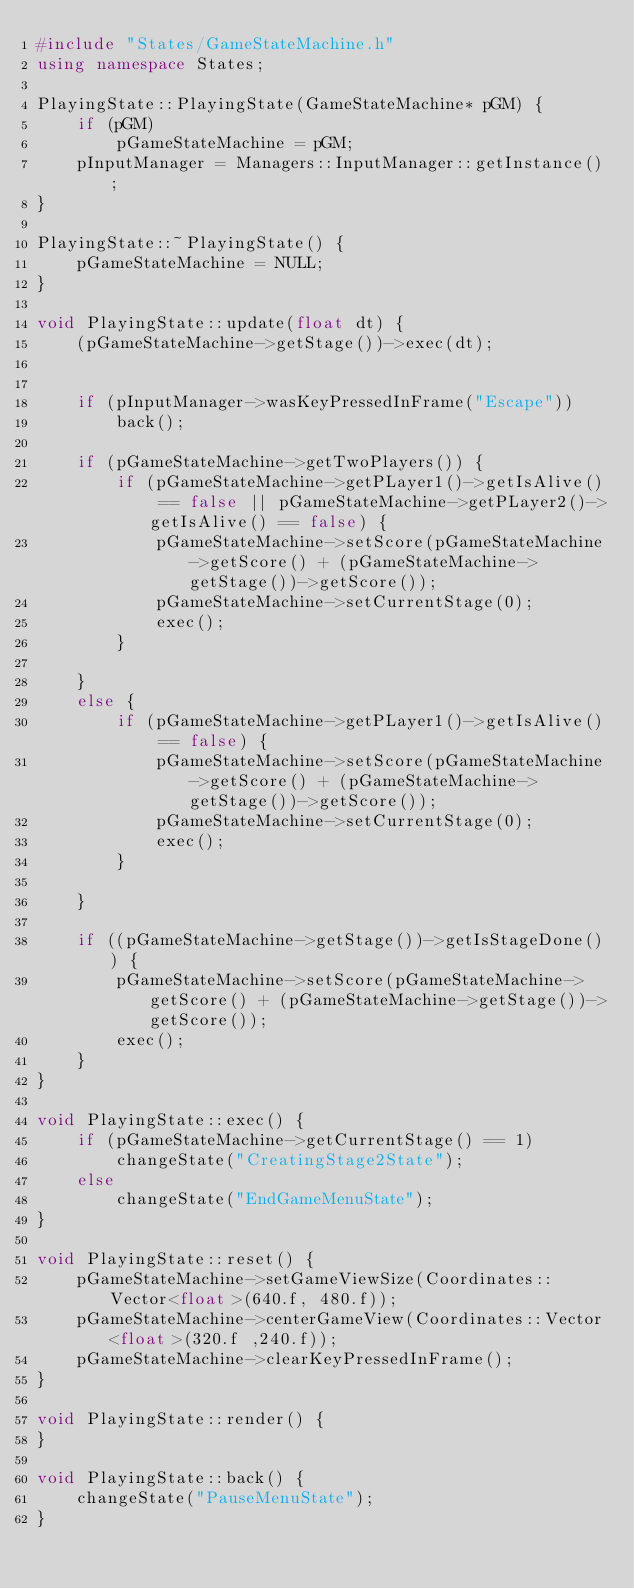<code> <loc_0><loc_0><loc_500><loc_500><_C++_>#include "States/GameStateMachine.h"
using namespace States;

PlayingState::PlayingState(GameStateMachine* pGM) {
    if (pGM)
        pGameStateMachine = pGM;
    pInputManager = Managers::InputManager::getInstance();
}

PlayingState::~PlayingState() {
    pGameStateMachine = NULL;
}

void PlayingState::update(float dt) {
    (pGameStateMachine->getStage())->exec(dt);


    if (pInputManager->wasKeyPressedInFrame("Escape"))
        back();

    if (pGameStateMachine->getTwoPlayers()) {
        if (pGameStateMachine->getPLayer1()->getIsAlive() == false || pGameStateMachine->getPLayer2()->getIsAlive() == false) {
            pGameStateMachine->setScore(pGameStateMachine->getScore() + (pGameStateMachine->getStage())->getScore());
            pGameStateMachine->setCurrentStage(0);
            exec();
        }

    }
    else {
        if (pGameStateMachine->getPLayer1()->getIsAlive() == false) {
            pGameStateMachine->setScore(pGameStateMachine->getScore() + (pGameStateMachine->getStage())->getScore());
            pGameStateMachine->setCurrentStage(0);
            exec();
        }

    }

    if ((pGameStateMachine->getStage())->getIsStageDone()) {
        pGameStateMachine->setScore(pGameStateMachine->getScore() + (pGameStateMachine->getStage())->getScore());
        exec();
    }
}

void PlayingState::exec() {
    if (pGameStateMachine->getCurrentStage() == 1)
        changeState("CreatingStage2State");
    else
        changeState("EndGameMenuState");
}

void PlayingState::reset() {
    pGameStateMachine->setGameViewSize(Coordinates::Vector<float>(640.f, 480.f));
    pGameStateMachine->centerGameView(Coordinates::Vector<float>(320.f ,240.f));
    pGameStateMachine->clearKeyPressedInFrame();
}

void PlayingState::render() {
}

void PlayingState::back() {
    changeState("PauseMenuState");
}

</code> 